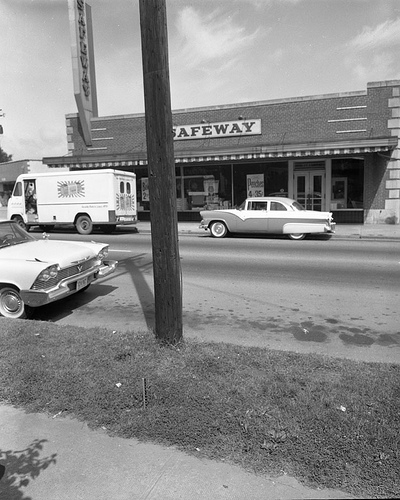Please transcribe the text information in this image. SAFEWAY 